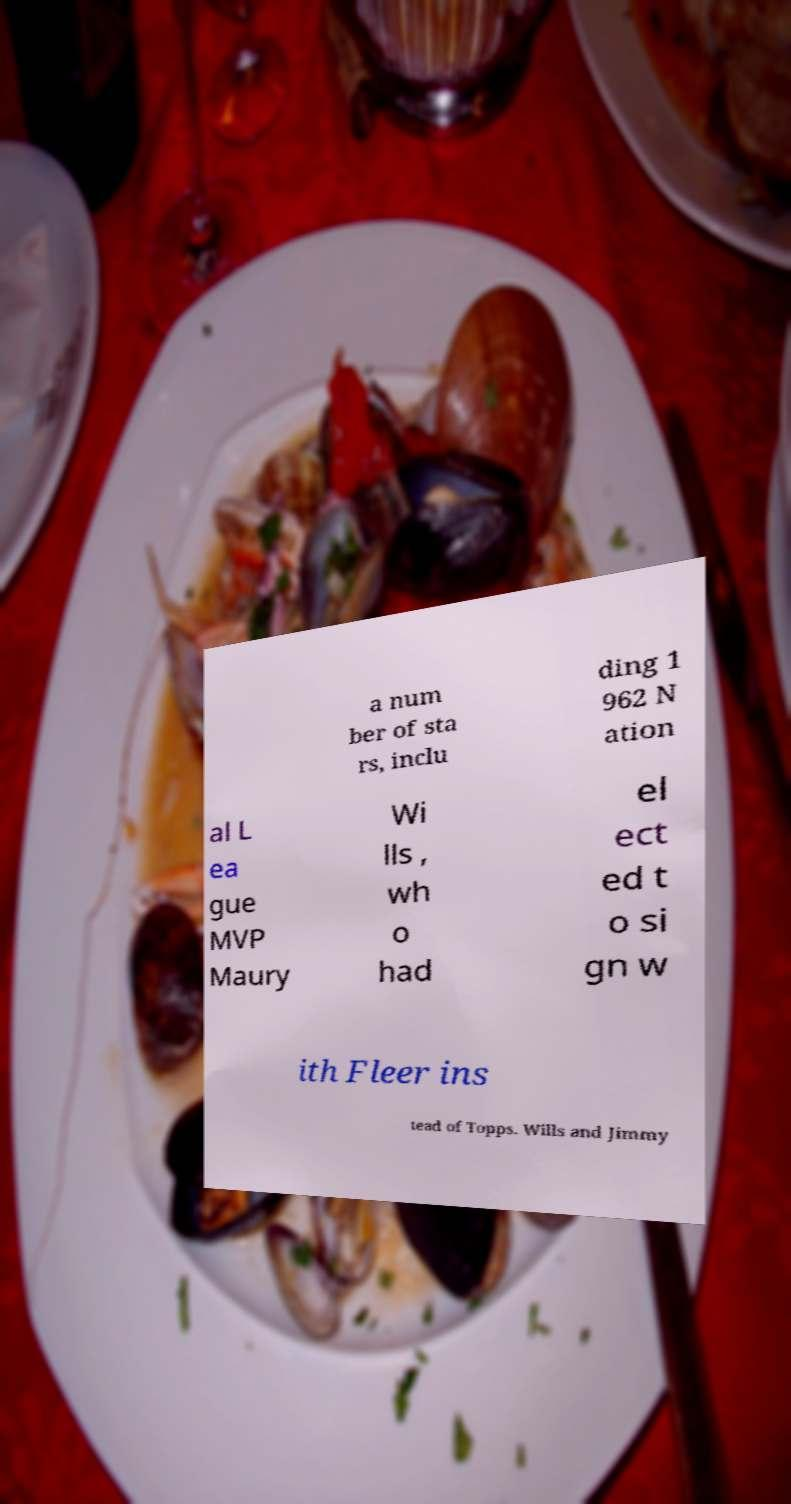Please read and relay the text visible in this image. What does it say? a num ber of sta rs, inclu ding 1 962 N ation al L ea gue MVP Maury Wi lls , wh o had el ect ed t o si gn w ith Fleer ins tead of Topps. Wills and Jimmy 